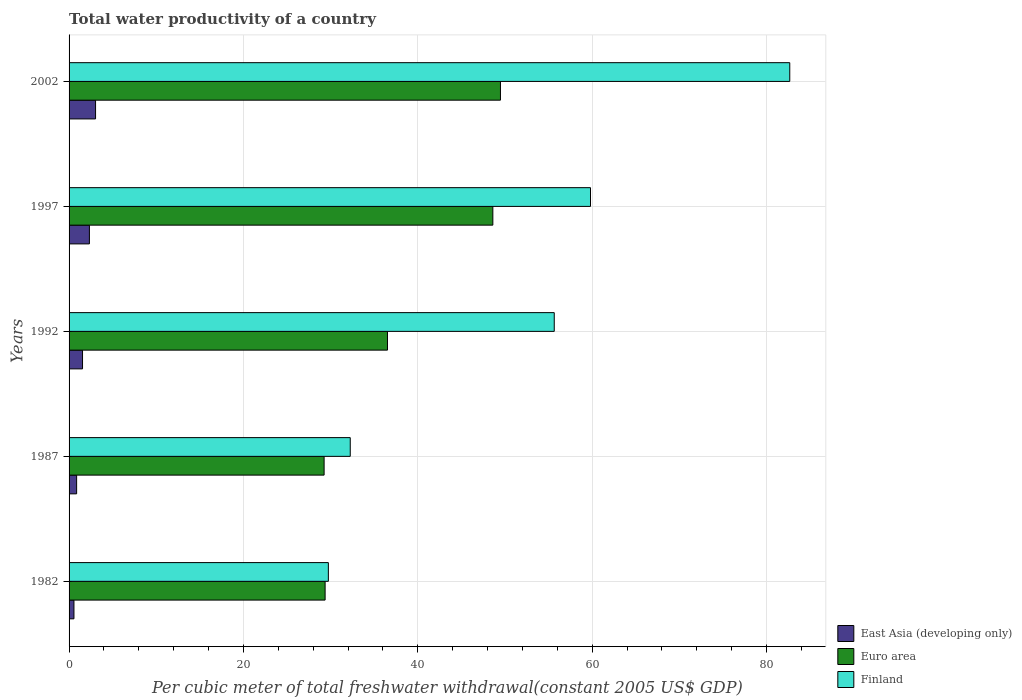Are the number of bars on each tick of the Y-axis equal?
Your answer should be compact. Yes. How many bars are there on the 3rd tick from the bottom?
Offer a terse response. 3. What is the label of the 4th group of bars from the top?
Offer a very short reply. 1987. What is the total water productivity in East Asia (developing only) in 1982?
Provide a succinct answer. 0.56. Across all years, what is the maximum total water productivity in Euro area?
Your response must be concise. 49.48. Across all years, what is the minimum total water productivity in Euro area?
Your answer should be very brief. 29.25. In which year was the total water productivity in Euro area maximum?
Offer a very short reply. 2002. What is the total total water productivity in Finland in the graph?
Offer a terse response. 260.12. What is the difference between the total water productivity in Finland in 1992 and that in 1997?
Ensure brevity in your answer.  -4.16. What is the difference between the total water productivity in Finland in 1987 and the total water productivity in East Asia (developing only) in 1982?
Your response must be concise. 31.69. What is the average total water productivity in Finland per year?
Offer a very short reply. 52.02. In the year 1982, what is the difference between the total water productivity in East Asia (developing only) and total water productivity in Finland?
Your answer should be very brief. -29.18. In how many years, is the total water productivity in East Asia (developing only) greater than 68 US$?
Your response must be concise. 0. What is the ratio of the total water productivity in Finland in 1987 to that in 2002?
Your answer should be compact. 0.39. Is the difference between the total water productivity in East Asia (developing only) in 1987 and 2002 greater than the difference between the total water productivity in Finland in 1987 and 2002?
Provide a succinct answer. Yes. What is the difference between the highest and the second highest total water productivity in Finland?
Make the answer very short. 22.86. What is the difference between the highest and the lowest total water productivity in Euro area?
Provide a short and direct response. 20.23. In how many years, is the total water productivity in East Asia (developing only) greater than the average total water productivity in East Asia (developing only) taken over all years?
Give a very brief answer. 2. Is the sum of the total water productivity in Euro area in 1987 and 1992 greater than the maximum total water productivity in Finland across all years?
Ensure brevity in your answer.  No. What does the 3rd bar from the bottom in 1987 represents?
Give a very brief answer. Finland. Is it the case that in every year, the sum of the total water productivity in Finland and total water productivity in Euro area is greater than the total water productivity in East Asia (developing only)?
Provide a succinct answer. Yes. Are all the bars in the graph horizontal?
Make the answer very short. Yes. What is the difference between two consecutive major ticks on the X-axis?
Offer a terse response. 20. Does the graph contain grids?
Give a very brief answer. Yes. Where does the legend appear in the graph?
Your response must be concise. Bottom right. What is the title of the graph?
Your answer should be compact. Total water productivity of a country. Does "Mali" appear as one of the legend labels in the graph?
Offer a very short reply. No. What is the label or title of the X-axis?
Offer a terse response. Per cubic meter of total freshwater withdrawal(constant 2005 US$ GDP). What is the label or title of the Y-axis?
Ensure brevity in your answer.  Years. What is the Per cubic meter of total freshwater withdrawal(constant 2005 US$ GDP) of East Asia (developing only) in 1982?
Provide a short and direct response. 0.56. What is the Per cubic meter of total freshwater withdrawal(constant 2005 US$ GDP) in Euro area in 1982?
Ensure brevity in your answer.  29.37. What is the Per cubic meter of total freshwater withdrawal(constant 2005 US$ GDP) of Finland in 1982?
Your response must be concise. 29.74. What is the Per cubic meter of total freshwater withdrawal(constant 2005 US$ GDP) of East Asia (developing only) in 1987?
Your response must be concise. 0.87. What is the Per cubic meter of total freshwater withdrawal(constant 2005 US$ GDP) in Euro area in 1987?
Offer a terse response. 29.25. What is the Per cubic meter of total freshwater withdrawal(constant 2005 US$ GDP) in Finland in 1987?
Make the answer very short. 32.25. What is the Per cubic meter of total freshwater withdrawal(constant 2005 US$ GDP) in East Asia (developing only) in 1992?
Your response must be concise. 1.54. What is the Per cubic meter of total freshwater withdrawal(constant 2005 US$ GDP) in Euro area in 1992?
Ensure brevity in your answer.  36.52. What is the Per cubic meter of total freshwater withdrawal(constant 2005 US$ GDP) of Finland in 1992?
Give a very brief answer. 55.65. What is the Per cubic meter of total freshwater withdrawal(constant 2005 US$ GDP) of East Asia (developing only) in 1997?
Your answer should be very brief. 2.33. What is the Per cubic meter of total freshwater withdrawal(constant 2005 US$ GDP) of Euro area in 1997?
Your answer should be very brief. 48.61. What is the Per cubic meter of total freshwater withdrawal(constant 2005 US$ GDP) in Finland in 1997?
Keep it short and to the point. 59.81. What is the Per cubic meter of total freshwater withdrawal(constant 2005 US$ GDP) of East Asia (developing only) in 2002?
Provide a short and direct response. 3.04. What is the Per cubic meter of total freshwater withdrawal(constant 2005 US$ GDP) in Euro area in 2002?
Make the answer very short. 49.48. What is the Per cubic meter of total freshwater withdrawal(constant 2005 US$ GDP) of Finland in 2002?
Your answer should be very brief. 82.67. Across all years, what is the maximum Per cubic meter of total freshwater withdrawal(constant 2005 US$ GDP) in East Asia (developing only)?
Ensure brevity in your answer.  3.04. Across all years, what is the maximum Per cubic meter of total freshwater withdrawal(constant 2005 US$ GDP) in Euro area?
Give a very brief answer. 49.48. Across all years, what is the maximum Per cubic meter of total freshwater withdrawal(constant 2005 US$ GDP) of Finland?
Ensure brevity in your answer.  82.67. Across all years, what is the minimum Per cubic meter of total freshwater withdrawal(constant 2005 US$ GDP) of East Asia (developing only)?
Make the answer very short. 0.56. Across all years, what is the minimum Per cubic meter of total freshwater withdrawal(constant 2005 US$ GDP) in Euro area?
Keep it short and to the point. 29.25. Across all years, what is the minimum Per cubic meter of total freshwater withdrawal(constant 2005 US$ GDP) in Finland?
Offer a terse response. 29.74. What is the total Per cubic meter of total freshwater withdrawal(constant 2005 US$ GDP) in East Asia (developing only) in the graph?
Make the answer very short. 8.34. What is the total Per cubic meter of total freshwater withdrawal(constant 2005 US$ GDP) of Euro area in the graph?
Make the answer very short. 193.23. What is the total Per cubic meter of total freshwater withdrawal(constant 2005 US$ GDP) in Finland in the graph?
Offer a terse response. 260.12. What is the difference between the Per cubic meter of total freshwater withdrawal(constant 2005 US$ GDP) in East Asia (developing only) in 1982 and that in 1987?
Your response must be concise. -0.31. What is the difference between the Per cubic meter of total freshwater withdrawal(constant 2005 US$ GDP) in Euro area in 1982 and that in 1987?
Keep it short and to the point. 0.11. What is the difference between the Per cubic meter of total freshwater withdrawal(constant 2005 US$ GDP) in Finland in 1982 and that in 1987?
Keep it short and to the point. -2.51. What is the difference between the Per cubic meter of total freshwater withdrawal(constant 2005 US$ GDP) in East Asia (developing only) in 1982 and that in 1992?
Ensure brevity in your answer.  -0.98. What is the difference between the Per cubic meter of total freshwater withdrawal(constant 2005 US$ GDP) of Euro area in 1982 and that in 1992?
Make the answer very short. -7.15. What is the difference between the Per cubic meter of total freshwater withdrawal(constant 2005 US$ GDP) in Finland in 1982 and that in 1992?
Provide a succinct answer. -25.91. What is the difference between the Per cubic meter of total freshwater withdrawal(constant 2005 US$ GDP) in East Asia (developing only) in 1982 and that in 1997?
Make the answer very short. -1.77. What is the difference between the Per cubic meter of total freshwater withdrawal(constant 2005 US$ GDP) in Euro area in 1982 and that in 1997?
Make the answer very short. -19.24. What is the difference between the Per cubic meter of total freshwater withdrawal(constant 2005 US$ GDP) of Finland in 1982 and that in 1997?
Keep it short and to the point. -30.07. What is the difference between the Per cubic meter of total freshwater withdrawal(constant 2005 US$ GDP) in East Asia (developing only) in 1982 and that in 2002?
Your answer should be compact. -2.48. What is the difference between the Per cubic meter of total freshwater withdrawal(constant 2005 US$ GDP) of Euro area in 1982 and that in 2002?
Provide a succinct answer. -20.11. What is the difference between the Per cubic meter of total freshwater withdrawal(constant 2005 US$ GDP) in Finland in 1982 and that in 2002?
Your response must be concise. -52.92. What is the difference between the Per cubic meter of total freshwater withdrawal(constant 2005 US$ GDP) of East Asia (developing only) in 1987 and that in 1992?
Your answer should be very brief. -0.68. What is the difference between the Per cubic meter of total freshwater withdrawal(constant 2005 US$ GDP) of Euro area in 1987 and that in 1992?
Your answer should be very brief. -7.27. What is the difference between the Per cubic meter of total freshwater withdrawal(constant 2005 US$ GDP) of Finland in 1987 and that in 1992?
Keep it short and to the point. -23.4. What is the difference between the Per cubic meter of total freshwater withdrawal(constant 2005 US$ GDP) in East Asia (developing only) in 1987 and that in 1997?
Give a very brief answer. -1.47. What is the difference between the Per cubic meter of total freshwater withdrawal(constant 2005 US$ GDP) of Euro area in 1987 and that in 1997?
Your answer should be compact. -19.35. What is the difference between the Per cubic meter of total freshwater withdrawal(constant 2005 US$ GDP) in Finland in 1987 and that in 1997?
Ensure brevity in your answer.  -27.56. What is the difference between the Per cubic meter of total freshwater withdrawal(constant 2005 US$ GDP) of East Asia (developing only) in 1987 and that in 2002?
Provide a short and direct response. -2.17. What is the difference between the Per cubic meter of total freshwater withdrawal(constant 2005 US$ GDP) of Euro area in 1987 and that in 2002?
Keep it short and to the point. -20.23. What is the difference between the Per cubic meter of total freshwater withdrawal(constant 2005 US$ GDP) in Finland in 1987 and that in 2002?
Your response must be concise. -50.41. What is the difference between the Per cubic meter of total freshwater withdrawal(constant 2005 US$ GDP) of East Asia (developing only) in 1992 and that in 1997?
Provide a succinct answer. -0.79. What is the difference between the Per cubic meter of total freshwater withdrawal(constant 2005 US$ GDP) of Euro area in 1992 and that in 1997?
Make the answer very short. -12.09. What is the difference between the Per cubic meter of total freshwater withdrawal(constant 2005 US$ GDP) of Finland in 1992 and that in 1997?
Give a very brief answer. -4.16. What is the difference between the Per cubic meter of total freshwater withdrawal(constant 2005 US$ GDP) in East Asia (developing only) in 1992 and that in 2002?
Keep it short and to the point. -1.49. What is the difference between the Per cubic meter of total freshwater withdrawal(constant 2005 US$ GDP) in Euro area in 1992 and that in 2002?
Offer a very short reply. -12.96. What is the difference between the Per cubic meter of total freshwater withdrawal(constant 2005 US$ GDP) in Finland in 1992 and that in 2002?
Offer a very short reply. -27.02. What is the difference between the Per cubic meter of total freshwater withdrawal(constant 2005 US$ GDP) of East Asia (developing only) in 1997 and that in 2002?
Your answer should be compact. -0.71. What is the difference between the Per cubic meter of total freshwater withdrawal(constant 2005 US$ GDP) in Euro area in 1997 and that in 2002?
Offer a very short reply. -0.87. What is the difference between the Per cubic meter of total freshwater withdrawal(constant 2005 US$ GDP) in Finland in 1997 and that in 2002?
Your answer should be very brief. -22.86. What is the difference between the Per cubic meter of total freshwater withdrawal(constant 2005 US$ GDP) of East Asia (developing only) in 1982 and the Per cubic meter of total freshwater withdrawal(constant 2005 US$ GDP) of Euro area in 1987?
Give a very brief answer. -28.69. What is the difference between the Per cubic meter of total freshwater withdrawal(constant 2005 US$ GDP) in East Asia (developing only) in 1982 and the Per cubic meter of total freshwater withdrawal(constant 2005 US$ GDP) in Finland in 1987?
Your response must be concise. -31.69. What is the difference between the Per cubic meter of total freshwater withdrawal(constant 2005 US$ GDP) in Euro area in 1982 and the Per cubic meter of total freshwater withdrawal(constant 2005 US$ GDP) in Finland in 1987?
Offer a very short reply. -2.88. What is the difference between the Per cubic meter of total freshwater withdrawal(constant 2005 US$ GDP) of East Asia (developing only) in 1982 and the Per cubic meter of total freshwater withdrawal(constant 2005 US$ GDP) of Euro area in 1992?
Offer a terse response. -35.96. What is the difference between the Per cubic meter of total freshwater withdrawal(constant 2005 US$ GDP) in East Asia (developing only) in 1982 and the Per cubic meter of total freshwater withdrawal(constant 2005 US$ GDP) in Finland in 1992?
Give a very brief answer. -55.09. What is the difference between the Per cubic meter of total freshwater withdrawal(constant 2005 US$ GDP) of Euro area in 1982 and the Per cubic meter of total freshwater withdrawal(constant 2005 US$ GDP) of Finland in 1992?
Make the answer very short. -26.28. What is the difference between the Per cubic meter of total freshwater withdrawal(constant 2005 US$ GDP) in East Asia (developing only) in 1982 and the Per cubic meter of total freshwater withdrawal(constant 2005 US$ GDP) in Euro area in 1997?
Your answer should be compact. -48.05. What is the difference between the Per cubic meter of total freshwater withdrawal(constant 2005 US$ GDP) in East Asia (developing only) in 1982 and the Per cubic meter of total freshwater withdrawal(constant 2005 US$ GDP) in Finland in 1997?
Keep it short and to the point. -59.25. What is the difference between the Per cubic meter of total freshwater withdrawal(constant 2005 US$ GDP) in Euro area in 1982 and the Per cubic meter of total freshwater withdrawal(constant 2005 US$ GDP) in Finland in 1997?
Ensure brevity in your answer.  -30.44. What is the difference between the Per cubic meter of total freshwater withdrawal(constant 2005 US$ GDP) of East Asia (developing only) in 1982 and the Per cubic meter of total freshwater withdrawal(constant 2005 US$ GDP) of Euro area in 2002?
Offer a terse response. -48.92. What is the difference between the Per cubic meter of total freshwater withdrawal(constant 2005 US$ GDP) of East Asia (developing only) in 1982 and the Per cubic meter of total freshwater withdrawal(constant 2005 US$ GDP) of Finland in 2002?
Keep it short and to the point. -82.11. What is the difference between the Per cubic meter of total freshwater withdrawal(constant 2005 US$ GDP) of Euro area in 1982 and the Per cubic meter of total freshwater withdrawal(constant 2005 US$ GDP) of Finland in 2002?
Keep it short and to the point. -53.3. What is the difference between the Per cubic meter of total freshwater withdrawal(constant 2005 US$ GDP) in East Asia (developing only) in 1987 and the Per cubic meter of total freshwater withdrawal(constant 2005 US$ GDP) in Euro area in 1992?
Ensure brevity in your answer.  -35.66. What is the difference between the Per cubic meter of total freshwater withdrawal(constant 2005 US$ GDP) in East Asia (developing only) in 1987 and the Per cubic meter of total freshwater withdrawal(constant 2005 US$ GDP) in Finland in 1992?
Your response must be concise. -54.78. What is the difference between the Per cubic meter of total freshwater withdrawal(constant 2005 US$ GDP) of Euro area in 1987 and the Per cubic meter of total freshwater withdrawal(constant 2005 US$ GDP) of Finland in 1992?
Your answer should be compact. -26.4. What is the difference between the Per cubic meter of total freshwater withdrawal(constant 2005 US$ GDP) in East Asia (developing only) in 1987 and the Per cubic meter of total freshwater withdrawal(constant 2005 US$ GDP) in Euro area in 1997?
Your response must be concise. -47.74. What is the difference between the Per cubic meter of total freshwater withdrawal(constant 2005 US$ GDP) in East Asia (developing only) in 1987 and the Per cubic meter of total freshwater withdrawal(constant 2005 US$ GDP) in Finland in 1997?
Provide a succinct answer. -58.94. What is the difference between the Per cubic meter of total freshwater withdrawal(constant 2005 US$ GDP) in Euro area in 1987 and the Per cubic meter of total freshwater withdrawal(constant 2005 US$ GDP) in Finland in 1997?
Give a very brief answer. -30.56. What is the difference between the Per cubic meter of total freshwater withdrawal(constant 2005 US$ GDP) of East Asia (developing only) in 1987 and the Per cubic meter of total freshwater withdrawal(constant 2005 US$ GDP) of Euro area in 2002?
Keep it short and to the point. -48.61. What is the difference between the Per cubic meter of total freshwater withdrawal(constant 2005 US$ GDP) of East Asia (developing only) in 1987 and the Per cubic meter of total freshwater withdrawal(constant 2005 US$ GDP) of Finland in 2002?
Offer a terse response. -81.8. What is the difference between the Per cubic meter of total freshwater withdrawal(constant 2005 US$ GDP) in Euro area in 1987 and the Per cubic meter of total freshwater withdrawal(constant 2005 US$ GDP) in Finland in 2002?
Offer a terse response. -53.41. What is the difference between the Per cubic meter of total freshwater withdrawal(constant 2005 US$ GDP) in East Asia (developing only) in 1992 and the Per cubic meter of total freshwater withdrawal(constant 2005 US$ GDP) in Euro area in 1997?
Provide a succinct answer. -47.06. What is the difference between the Per cubic meter of total freshwater withdrawal(constant 2005 US$ GDP) of East Asia (developing only) in 1992 and the Per cubic meter of total freshwater withdrawal(constant 2005 US$ GDP) of Finland in 1997?
Your answer should be very brief. -58.27. What is the difference between the Per cubic meter of total freshwater withdrawal(constant 2005 US$ GDP) in Euro area in 1992 and the Per cubic meter of total freshwater withdrawal(constant 2005 US$ GDP) in Finland in 1997?
Ensure brevity in your answer.  -23.29. What is the difference between the Per cubic meter of total freshwater withdrawal(constant 2005 US$ GDP) of East Asia (developing only) in 1992 and the Per cubic meter of total freshwater withdrawal(constant 2005 US$ GDP) of Euro area in 2002?
Make the answer very short. -47.94. What is the difference between the Per cubic meter of total freshwater withdrawal(constant 2005 US$ GDP) in East Asia (developing only) in 1992 and the Per cubic meter of total freshwater withdrawal(constant 2005 US$ GDP) in Finland in 2002?
Keep it short and to the point. -81.12. What is the difference between the Per cubic meter of total freshwater withdrawal(constant 2005 US$ GDP) in Euro area in 1992 and the Per cubic meter of total freshwater withdrawal(constant 2005 US$ GDP) in Finland in 2002?
Your response must be concise. -46.14. What is the difference between the Per cubic meter of total freshwater withdrawal(constant 2005 US$ GDP) of East Asia (developing only) in 1997 and the Per cubic meter of total freshwater withdrawal(constant 2005 US$ GDP) of Euro area in 2002?
Keep it short and to the point. -47.15. What is the difference between the Per cubic meter of total freshwater withdrawal(constant 2005 US$ GDP) of East Asia (developing only) in 1997 and the Per cubic meter of total freshwater withdrawal(constant 2005 US$ GDP) of Finland in 2002?
Your answer should be very brief. -80.33. What is the difference between the Per cubic meter of total freshwater withdrawal(constant 2005 US$ GDP) of Euro area in 1997 and the Per cubic meter of total freshwater withdrawal(constant 2005 US$ GDP) of Finland in 2002?
Provide a short and direct response. -34.06. What is the average Per cubic meter of total freshwater withdrawal(constant 2005 US$ GDP) in East Asia (developing only) per year?
Provide a succinct answer. 1.67. What is the average Per cubic meter of total freshwater withdrawal(constant 2005 US$ GDP) of Euro area per year?
Offer a very short reply. 38.65. What is the average Per cubic meter of total freshwater withdrawal(constant 2005 US$ GDP) of Finland per year?
Give a very brief answer. 52.02. In the year 1982, what is the difference between the Per cubic meter of total freshwater withdrawal(constant 2005 US$ GDP) in East Asia (developing only) and Per cubic meter of total freshwater withdrawal(constant 2005 US$ GDP) in Euro area?
Provide a succinct answer. -28.81. In the year 1982, what is the difference between the Per cubic meter of total freshwater withdrawal(constant 2005 US$ GDP) in East Asia (developing only) and Per cubic meter of total freshwater withdrawal(constant 2005 US$ GDP) in Finland?
Ensure brevity in your answer.  -29.18. In the year 1982, what is the difference between the Per cubic meter of total freshwater withdrawal(constant 2005 US$ GDP) of Euro area and Per cubic meter of total freshwater withdrawal(constant 2005 US$ GDP) of Finland?
Make the answer very short. -0.37. In the year 1987, what is the difference between the Per cubic meter of total freshwater withdrawal(constant 2005 US$ GDP) of East Asia (developing only) and Per cubic meter of total freshwater withdrawal(constant 2005 US$ GDP) of Euro area?
Provide a succinct answer. -28.39. In the year 1987, what is the difference between the Per cubic meter of total freshwater withdrawal(constant 2005 US$ GDP) in East Asia (developing only) and Per cubic meter of total freshwater withdrawal(constant 2005 US$ GDP) in Finland?
Offer a terse response. -31.38. In the year 1987, what is the difference between the Per cubic meter of total freshwater withdrawal(constant 2005 US$ GDP) of Euro area and Per cubic meter of total freshwater withdrawal(constant 2005 US$ GDP) of Finland?
Give a very brief answer. -3. In the year 1992, what is the difference between the Per cubic meter of total freshwater withdrawal(constant 2005 US$ GDP) in East Asia (developing only) and Per cubic meter of total freshwater withdrawal(constant 2005 US$ GDP) in Euro area?
Offer a terse response. -34.98. In the year 1992, what is the difference between the Per cubic meter of total freshwater withdrawal(constant 2005 US$ GDP) of East Asia (developing only) and Per cubic meter of total freshwater withdrawal(constant 2005 US$ GDP) of Finland?
Offer a very short reply. -54.11. In the year 1992, what is the difference between the Per cubic meter of total freshwater withdrawal(constant 2005 US$ GDP) of Euro area and Per cubic meter of total freshwater withdrawal(constant 2005 US$ GDP) of Finland?
Provide a succinct answer. -19.13. In the year 1997, what is the difference between the Per cubic meter of total freshwater withdrawal(constant 2005 US$ GDP) in East Asia (developing only) and Per cubic meter of total freshwater withdrawal(constant 2005 US$ GDP) in Euro area?
Give a very brief answer. -46.28. In the year 1997, what is the difference between the Per cubic meter of total freshwater withdrawal(constant 2005 US$ GDP) of East Asia (developing only) and Per cubic meter of total freshwater withdrawal(constant 2005 US$ GDP) of Finland?
Make the answer very short. -57.48. In the year 1997, what is the difference between the Per cubic meter of total freshwater withdrawal(constant 2005 US$ GDP) in Euro area and Per cubic meter of total freshwater withdrawal(constant 2005 US$ GDP) in Finland?
Offer a terse response. -11.2. In the year 2002, what is the difference between the Per cubic meter of total freshwater withdrawal(constant 2005 US$ GDP) in East Asia (developing only) and Per cubic meter of total freshwater withdrawal(constant 2005 US$ GDP) in Euro area?
Your answer should be very brief. -46.44. In the year 2002, what is the difference between the Per cubic meter of total freshwater withdrawal(constant 2005 US$ GDP) in East Asia (developing only) and Per cubic meter of total freshwater withdrawal(constant 2005 US$ GDP) in Finland?
Offer a very short reply. -79.63. In the year 2002, what is the difference between the Per cubic meter of total freshwater withdrawal(constant 2005 US$ GDP) in Euro area and Per cubic meter of total freshwater withdrawal(constant 2005 US$ GDP) in Finland?
Give a very brief answer. -33.19. What is the ratio of the Per cubic meter of total freshwater withdrawal(constant 2005 US$ GDP) in East Asia (developing only) in 1982 to that in 1987?
Your answer should be compact. 0.65. What is the ratio of the Per cubic meter of total freshwater withdrawal(constant 2005 US$ GDP) of Euro area in 1982 to that in 1987?
Keep it short and to the point. 1. What is the ratio of the Per cubic meter of total freshwater withdrawal(constant 2005 US$ GDP) in Finland in 1982 to that in 1987?
Make the answer very short. 0.92. What is the ratio of the Per cubic meter of total freshwater withdrawal(constant 2005 US$ GDP) in East Asia (developing only) in 1982 to that in 1992?
Offer a very short reply. 0.36. What is the ratio of the Per cubic meter of total freshwater withdrawal(constant 2005 US$ GDP) in Euro area in 1982 to that in 1992?
Provide a short and direct response. 0.8. What is the ratio of the Per cubic meter of total freshwater withdrawal(constant 2005 US$ GDP) in Finland in 1982 to that in 1992?
Ensure brevity in your answer.  0.53. What is the ratio of the Per cubic meter of total freshwater withdrawal(constant 2005 US$ GDP) of East Asia (developing only) in 1982 to that in 1997?
Your response must be concise. 0.24. What is the ratio of the Per cubic meter of total freshwater withdrawal(constant 2005 US$ GDP) of Euro area in 1982 to that in 1997?
Make the answer very short. 0.6. What is the ratio of the Per cubic meter of total freshwater withdrawal(constant 2005 US$ GDP) of Finland in 1982 to that in 1997?
Provide a succinct answer. 0.5. What is the ratio of the Per cubic meter of total freshwater withdrawal(constant 2005 US$ GDP) in East Asia (developing only) in 1982 to that in 2002?
Your answer should be compact. 0.18. What is the ratio of the Per cubic meter of total freshwater withdrawal(constant 2005 US$ GDP) in Euro area in 1982 to that in 2002?
Make the answer very short. 0.59. What is the ratio of the Per cubic meter of total freshwater withdrawal(constant 2005 US$ GDP) of Finland in 1982 to that in 2002?
Your answer should be compact. 0.36. What is the ratio of the Per cubic meter of total freshwater withdrawal(constant 2005 US$ GDP) in East Asia (developing only) in 1987 to that in 1992?
Ensure brevity in your answer.  0.56. What is the ratio of the Per cubic meter of total freshwater withdrawal(constant 2005 US$ GDP) in Euro area in 1987 to that in 1992?
Offer a terse response. 0.8. What is the ratio of the Per cubic meter of total freshwater withdrawal(constant 2005 US$ GDP) of Finland in 1987 to that in 1992?
Provide a short and direct response. 0.58. What is the ratio of the Per cubic meter of total freshwater withdrawal(constant 2005 US$ GDP) of East Asia (developing only) in 1987 to that in 1997?
Offer a very short reply. 0.37. What is the ratio of the Per cubic meter of total freshwater withdrawal(constant 2005 US$ GDP) in Euro area in 1987 to that in 1997?
Offer a terse response. 0.6. What is the ratio of the Per cubic meter of total freshwater withdrawal(constant 2005 US$ GDP) of Finland in 1987 to that in 1997?
Ensure brevity in your answer.  0.54. What is the ratio of the Per cubic meter of total freshwater withdrawal(constant 2005 US$ GDP) of East Asia (developing only) in 1987 to that in 2002?
Your answer should be very brief. 0.29. What is the ratio of the Per cubic meter of total freshwater withdrawal(constant 2005 US$ GDP) in Euro area in 1987 to that in 2002?
Ensure brevity in your answer.  0.59. What is the ratio of the Per cubic meter of total freshwater withdrawal(constant 2005 US$ GDP) of Finland in 1987 to that in 2002?
Provide a succinct answer. 0.39. What is the ratio of the Per cubic meter of total freshwater withdrawal(constant 2005 US$ GDP) in East Asia (developing only) in 1992 to that in 1997?
Provide a succinct answer. 0.66. What is the ratio of the Per cubic meter of total freshwater withdrawal(constant 2005 US$ GDP) of Euro area in 1992 to that in 1997?
Your answer should be very brief. 0.75. What is the ratio of the Per cubic meter of total freshwater withdrawal(constant 2005 US$ GDP) of Finland in 1992 to that in 1997?
Your response must be concise. 0.93. What is the ratio of the Per cubic meter of total freshwater withdrawal(constant 2005 US$ GDP) of East Asia (developing only) in 1992 to that in 2002?
Offer a very short reply. 0.51. What is the ratio of the Per cubic meter of total freshwater withdrawal(constant 2005 US$ GDP) in Euro area in 1992 to that in 2002?
Offer a terse response. 0.74. What is the ratio of the Per cubic meter of total freshwater withdrawal(constant 2005 US$ GDP) of Finland in 1992 to that in 2002?
Provide a succinct answer. 0.67. What is the ratio of the Per cubic meter of total freshwater withdrawal(constant 2005 US$ GDP) in East Asia (developing only) in 1997 to that in 2002?
Offer a terse response. 0.77. What is the ratio of the Per cubic meter of total freshwater withdrawal(constant 2005 US$ GDP) of Euro area in 1997 to that in 2002?
Give a very brief answer. 0.98. What is the ratio of the Per cubic meter of total freshwater withdrawal(constant 2005 US$ GDP) in Finland in 1997 to that in 2002?
Offer a very short reply. 0.72. What is the difference between the highest and the second highest Per cubic meter of total freshwater withdrawal(constant 2005 US$ GDP) of East Asia (developing only)?
Offer a terse response. 0.71. What is the difference between the highest and the second highest Per cubic meter of total freshwater withdrawal(constant 2005 US$ GDP) of Euro area?
Provide a short and direct response. 0.87. What is the difference between the highest and the second highest Per cubic meter of total freshwater withdrawal(constant 2005 US$ GDP) of Finland?
Your answer should be very brief. 22.86. What is the difference between the highest and the lowest Per cubic meter of total freshwater withdrawal(constant 2005 US$ GDP) in East Asia (developing only)?
Keep it short and to the point. 2.48. What is the difference between the highest and the lowest Per cubic meter of total freshwater withdrawal(constant 2005 US$ GDP) in Euro area?
Provide a succinct answer. 20.23. What is the difference between the highest and the lowest Per cubic meter of total freshwater withdrawal(constant 2005 US$ GDP) in Finland?
Provide a succinct answer. 52.92. 